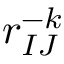<formula> <loc_0><loc_0><loc_500><loc_500>r _ { I J } ^ { - k }</formula> 